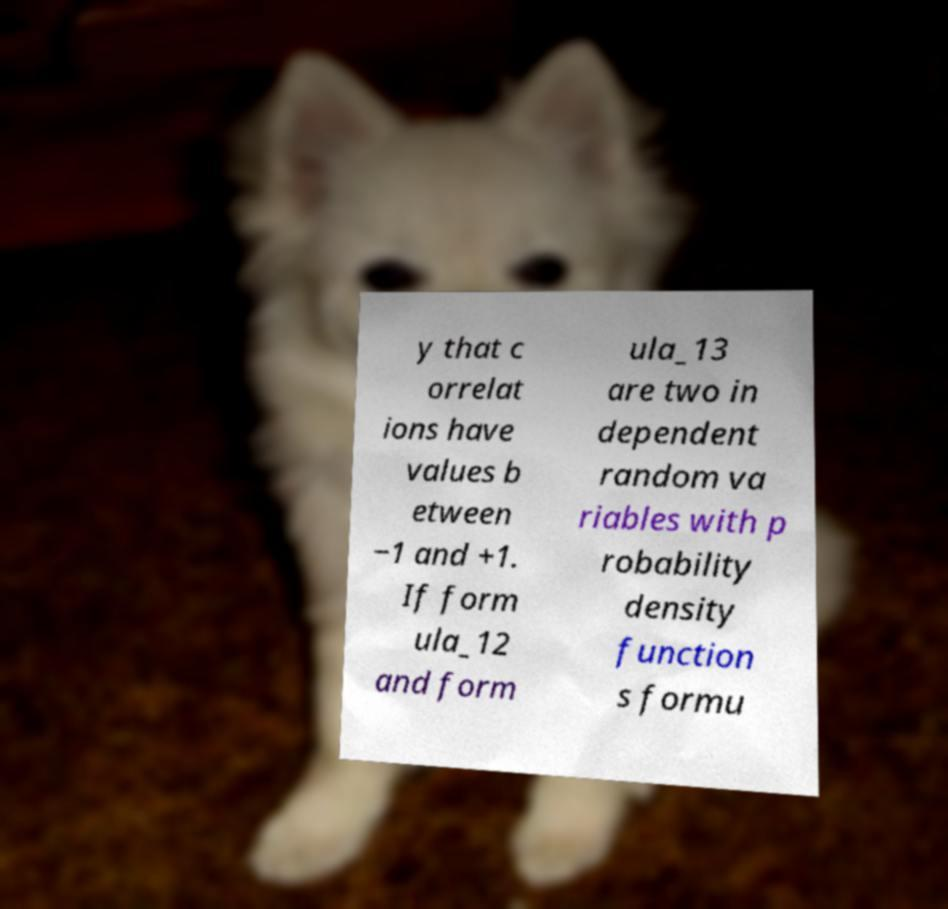Can you read and provide the text displayed in the image?This photo seems to have some interesting text. Can you extract and type it out for me? y that c orrelat ions have values b etween −1 and +1. If form ula_12 and form ula_13 are two in dependent random va riables with p robability density function s formu 